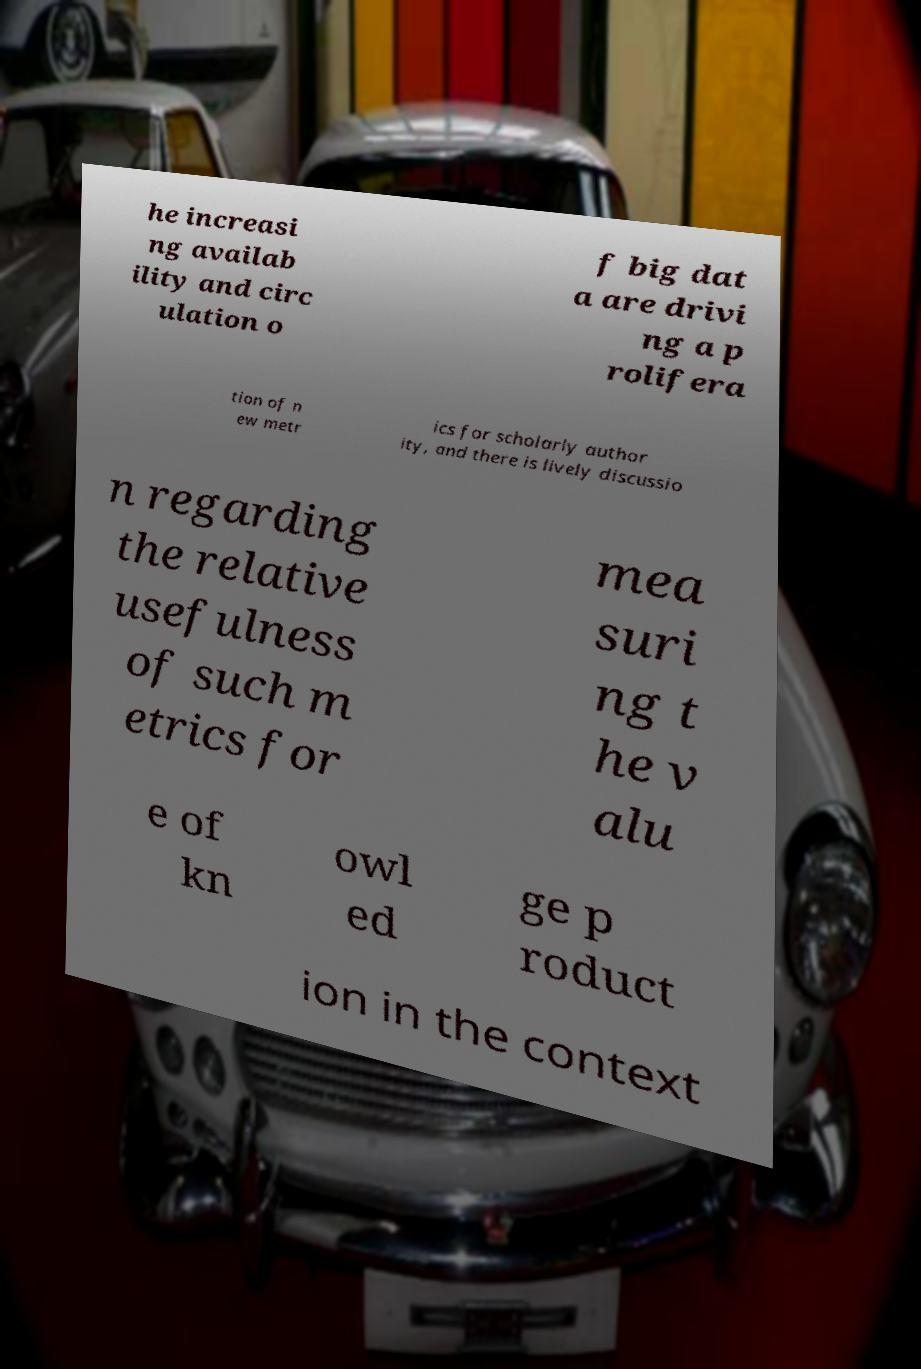What messages or text are displayed in this image? I need them in a readable, typed format. he increasi ng availab ility and circ ulation o f big dat a are drivi ng a p rolifera tion of n ew metr ics for scholarly author ity, and there is lively discussio n regarding the relative usefulness of such m etrics for mea suri ng t he v alu e of kn owl ed ge p roduct ion in the context 